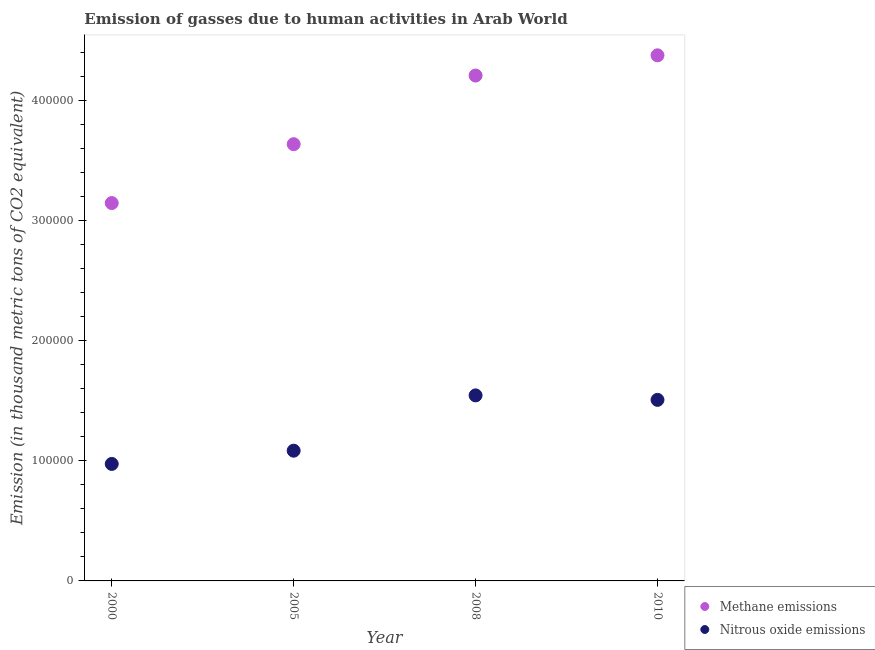How many different coloured dotlines are there?
Offer a very short reply. 2. Is the number of dotlines equal to the number of legend labels?
Keep it short and to the point. Yes. What is the amount of methane emissions in 2010?
Provide a short and direct response. 4.38e+05. Across all years, what is the maximum amount of nitrous oxide emissions?
Provide a short and direct response. 1.54e+05. Across all years, what is the minimum amount of nitrous oxide emissions?
Provide a succinct answer. 9.74e+04. What is the total amount of methane emissions in the graph?
Your answer should be very brief. 1.54e+06. What is the difference between the amount of nitrous oxide emissions in 2000 and that in 2005?
Offer a very short reply. -1.10e+04. What is the difference between the amount of nitrous oxide emissions in 2010 and the amount of methane emissions in 2005?
Offer a very short reply. -2.13e+05. What is the average amount of methane emissions per year?
Offer a terse response. 3.84e+05. In the year 2005, what is the difference between the amount of nitrous oxide emissions and amount of methane emissions?
Your answer should be very brief. -2.55e+05. In how many years, is the amount of nitrous oxide emissions greater than 120000 thousand metric tons?
Offer a terse response. 2. What is the ratio of the amount of methane emissions in 2005 to that in 2008?
Ensure brevity in your answer.  0.86. Is the amount of methane emissions in 2005 less than that in 2010?
Keep it short and to the point. Yes. What is the difference between the highest and the second highest amount of nitrous oxide emissions?
Make the answer very short. 3741.4. What is the difference between the highest and the lowest amount of methane emissions?
Make the answer very short. 1.23e+05. Is the sum of the amount of nitrous oxide emissions in 2008 and 2010 greater than the maximum amount of methane emissions across all years?
Your answer should be very brief. No. Does the amount of nitrous oxide emissions monotonically increase over the years?
Your response must be concise. No. Is the amount of methane emissions strictly greater than the amount of nitrous oxide emissions over the years?
Make the answer very short. Yes. Is the amount of nitrous oxide emissions strictly less than the amount of methane emissions over the years?
Offer a very short reply. Yes. How many dotlines are there?
Keep it short and to the point. 2. How many years are there in the graph?
Offer a terse response. 4. What is the difference between two consecutive major ticks on the Y-axis?
Make the answer very short. 1.00e+05. Are the values on the major ticks of Y-axis written in scientific E-notation?
Your answer should be very brief. No. Does the graph contain any zero values?
Your response must be concise. No. Does the graph contain grids?
Give a very brief answer. No. How many legend labels are there?
Give a very brief answer. 2. How are the legend labels stacked?
Ensure brevity in your answer.  Vertical. What is the title of the graph?
Your answer should be very brief. Emission of gasses due to human activities in Arab World. What is the label or title of the Y-axis?
Offer a very short reply. Emission (in thousand metric tons of CO2 equivalent). What is the Emission (in thousand metric tons of CO2 equivalent) of Methane emissions in 2000?
Your answer should be compact. 3.15e+05. What is the Emission (in thousand metric tons of CO2 equivalent) in Nitrous oxide emissions in 2000?
Provide a succinct answer. 9.74e+04. What is the Emission (in thousand metric tons of CO2 equivalent) of Methane emissions in 2005?
Offer a very short reply. 3.64e+05. What is the Emission (in thousand metric tons of CO2 equivalent) in Nitrous oxide emissions in 2005?
Offer a very short reply. 1.08e+05. What is the Emission (in thousand metric tons of CO2 equivalent) of Methane emissions in 2008?
Provide a succinct answer. 4.21e+05. What is the Emission (in thousand metric tons of CO2 equivalent) in Nitrous oxide emissions in 2008?
Make the answer very short. 1.54e+05. What is the Emission (in thousand metric tons of CO2 equivalent) of Methane emissions in 2010?
Offer a terse response. 4.38e+05. What is the Emission (in thousand metric tons of CO2 equivalent) of Nitrous oxide emissions in 2010?
Your response must be concise. 1.51e+05. Across all years, what is the maximum Emission (in thousand metric tons of CO2 equivalent) in Methane emissions?
Make the answer very short. 4.38e+05. Across all years, what is the maximum Emission (in thousand metric tons of CO2 equivalent) of Nitrous oxide emissions?
Give a very brief answer. 1.54e+05. Across all years, what is the minimum Emission (in thousand metric tons of CO2 equivalent) in Methane emissions?
Make the answer very short. 3.15e+05. Across all years, what is the minimum Emission (in thousand metric tons of CO2 equivalent) in Nitrous oxide emissions?
Ensure brevity in your answer.  9.74e+04. What is the total Emission (in thousand metric tons of CO2 equivalent) of Methane emissions in the graph?
Make the answer very short. 1.54e+06. What is the total Emission (in thousand metric tons of CO2 equivalent) of Nitrous oxide emissions in the graph?
Make the answer very short. 5.11e+05. What is the difference between the Emission (in thousand metric tons of CO2 equivalent) in Methane emissions in 2000 and that in 2005?
Make the answer very short. -4.90e+04. What is the difference between the Emission (in thousand metric tons of CO2 equivalent) of Nitrous oxide emissions in 2000 and that in 2005?
Make the answer very short. -1.10e+04. What is the difference between the Emission (in thousand metric tons of CO2 equivalent) in Methane emissions in 2000 and that in 2008?
Your answer should be compact. -1.06e+05. What is the difference between the Emission (in thousand metric tons of CO2 equivalent) in Nitrous oxide emissions in 2000 and that in 2008?
Offer a terse response. -5.71e+04. What is the difference between the Emission (in thousand metric tons of CO2 equivalent) in Methane emissions in 2000 and that in 2010?
Ensure brevity in your answer.  -1.23e+05. What is the difference between the Emission (in thousand metric tons of CO2 equivalent) of Nitrous oxide emissions in 2000 and that in 2010?
Keep it short and to the point. -5.33e+04. What is the difference between the Emission (in thousand metric tons of CO2 equivalent) in Methane emissions in 2005 and that in 2008?
Your response must be concise. -5.71e+04. What is the difference between the Emission (in thousand metric tons of CO2 equivalent) of Nitrous oxide emissions in 2005 and that in 2008?
Keep it short and to the point. -4.61e+04. What is the difference between the Emission (in thousand metric tons of CO2 equivalent) in Methane emissions in 2005 and that in 2010?
Ensure brevity in your answer.  -7.40e+04. What is the difference between the Emission (in thousand metric tons of CO2 equivalent) of Nitrous oxide emissions in 2005 and that in 2010?
Your answer should be very brief. -4.23e+04. What is the difference between the Emission (in thousand metric tons of CO2 equivalent) of Methane emissions in 2008 and that in 2010?
Offer a terse response. -1.69e+04. What is the difference between the Emission (in thousand metric tons of CO2 equivalent) in Nitrous oxide emissions in 2008 and that in 2010?
Provide a short and direct response. 3741.4. What is the difference between the Emission (in thousand metric tons of CO2 equivalent) in Methane emissions in 2000 and the Emission (in thousand metric tons of CO2 equivalent) in Nitrous oxide emissions in 2005?
Your response must be concise. 2.06e+05. What is the difference between the Emission (in thousand metric tons of CO2 equivalent) of Methane emissions in 2000 and the Emission (in thousand metric tons of CO2 equivalent) of Nitrous oxide emissions in 2008?
Your response must be concise. 1.60e+05. What is the difference between the Emission (in thousand metric tons of CO2 equivalent) of Methane emissions in 2000 and the Emission (in thousand metric tons of CO2 equivalent) of Nitrous oxide emissions in 2010?
Your response must be concise. 1.64e+05. What is the difference between the Emission (in thousand metric tons of CO2 equivalent) in Methane emissions in 2005 and the Emission (in thousand metric tons of CO2 equivalent) in Nitrous oxide emissions in 2008?
Your answer should be very brief. 2.09e+05. What is the difference between the Emission (in thousand metric tons of CO2 equivalent) in Methane emissions in 2005 and the Emission (in thousand metric tons of CO2 equivalent) in Nitrous oxide emissions in 2010?
Your answer should be very brief. 2.13e+05. What is the difference between the Emission (in thousand metric tons of CO2 equivalent) in Methane emissions in 2008 and the Emission (in thousand metric tons of CO2 equivalent) in Nitrous oxide emissions in 2010?
Give a very brief answer. 2.70e+05. What is the average Emission (in thousand metric tons of CO2 equivalent) of Methane emissions per year?
Ensure brevity in your answer.  3.84e+05. What is the average Emission (in thousand metric tons of CO2 equivalent) of Nitrous oxide emissions per year?
Your answer should be compact. 1.28e+05. In the year 2000, what is the difference between the Emission (in thousand metric tons of CO2 equivalent) of Methane emissions and Emission (in thousand metric tons of CO2 equivalent) of Nitrous oxide emissions?
Provide a succinct answer. 2.17e+05. In the year 2005, what is the difference between the Emission (in thousand metric tons of CO2 equivalent) in Methane emissions and Emission (in thousand metric tons of CO2 equivalent) in Nitrous oxide emissions?
Ensure brevity in your answer.  2.55e+05. In the year 2008, what is the difference between the Emission (in thousand metric tons of CO2 equivalent) of Methane emissions and Emission (in thousand metric tons of CO2 equivalent) of Nitrous oxide emissions?
Provide a succinct answer. 2.66e+05. In the year 2010, what is the difference between the Emission (in thousand metric tons of CO2 equivalent) of Methane emissions and Emission (in thousand metric tons of CO2 equivalent) of Nitrous oxide emissions?
Offer a terse response. 2.87e+05. What is the ratio of the Emission (in thousand metric tons of CO2 equivalent) in Methane emissions in 2000 to that in 2005?
Provide a succinct answer. 0.87. What is the ratio of the Emission (in thousand metric tons of CO2 equivalent) of Nitrous oxide emissions in 2000 to that in 2005?
Offer a very short reply. 0.9. What is the ratio of the Emission (in thousand metric tons of CO2 equivalent) in Methane emissions in 2000 to that in 2008?
Your answer should be very brief. 0.75. What is the ratio of the Emission (in thousand metric tons of CO2 equivalent) of Nitrous oxide emissions in 2000 to that in 2008?
Offer a terse response. 0.63. What is the ratio of the Emission (in thousand metric tons of CO2 equivalent) of Methane emissions in 2000 to that in 2010?
Your response must be concise. 0.72. What is the ratio of the Emission (in thousand metric tons of CO2 equivalent) of Nitrous oxide emissions in 2000 to that in 2010?
Offer a very short reply. 0.65. What is the ratio of the Emission (in thousand metric tons of CO2 equivalent) in Methane emissions in 2005 to that in 2008?
Make the answer very short. 0.86. What is the ratio of the Emission (in thousand metric tons of CO2 equivalent) of Nitrous oxide emissions in 2005 to that in 2008?
Your answer should be compact. 0.7. What is the ratio of the Emission (in thousand metric tons of CO2 equivalent) in Methane emissions in 2005 to that in 2010?
Give a very brief answer. 0.83. What is the ratio of the Emission (in thousand metric tons of CO2 equivalent) in Nitrous oxide emissions in 2005 to that in 2010?
Your answer should be compact. 0.72. What is the ratio of the Emission (in thousand metric tons of CO2 equivalent) of Methane emissions in 2008 to that in 2010?
Make the answer very short. 0.96. What is the ratio of the Emission (in thousand metric tons of CO2 equivalent) of Nitrous oxide emissions in 2008 to that in 2010?
Provide a succinct answer. 1.02. What is the difference between the highest and the second highest Emission (in thousand metric tons of CO2 equivalent) in Methane emissions?
Your answer should be compact. 1.69e+04. What is the difference between the highest and the second highest Emission (in thousand metric tons of CO2 equivalent) in Nitrous oxide emissions?
Your response must be concise. 3741.4. What is the difference between the highest and the lowest Emission (in thousand metric tons of CO2 equivalent) of Methane emissions?
Your answer should be very brief. 1.23e+05. What is the difference between the highest and the lowest Emission (in thousand metric tons of CO2 equivalent) of Nitrous oxide emissions?
Your response must be concise. 5.71e+04. 